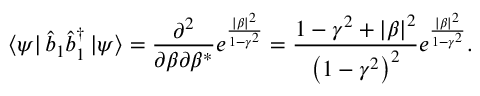<formula> <loc_0><loc_0><loc_500><loc_500>\left \langle \psi \right | \hat { b } _ { 1 } \hat { b } _ { 1 } ^ { \dagger } \left | \psi \right \rangle = \frac { \partial ^ { 2 } } { \partial \beta \partial \beta ^ { \ast } } e ^ { \frac { | \beta | ^ { 2 } } { 1 - \gamma ^ { 2 } } } = \frac { 1 - \gamma ^ { 2 } + \left | \beta \right | ^ { 2 } } { \left ( 1 - \gamma ^ { 2 } \right ) ^ { 2 } } e ^ { \frac { | \beta | ^ { 2 } } { 1 - \gamma ^ { 2 } } } .</formula> 